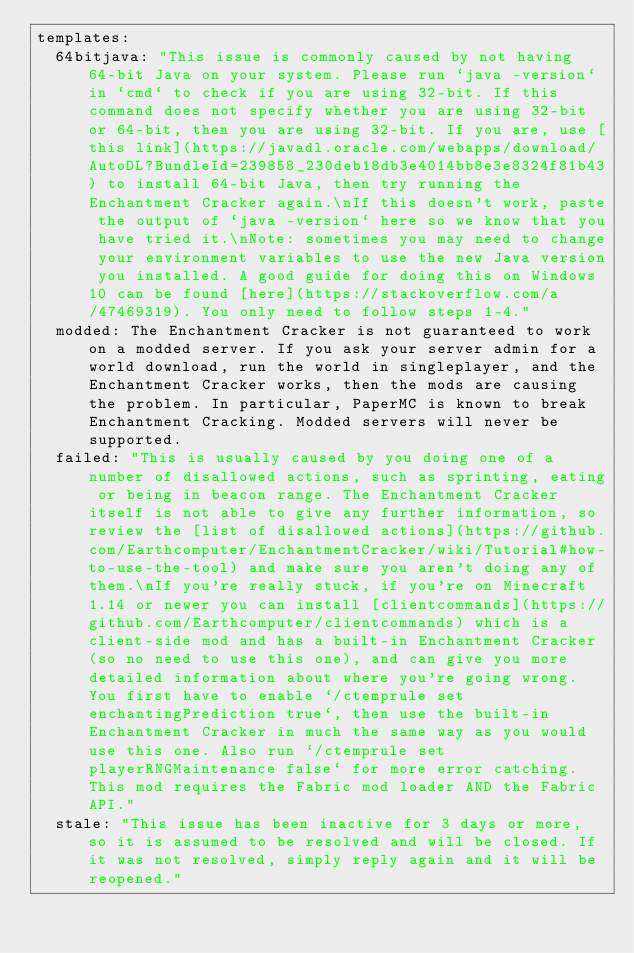Convert code to text. <code><loc_0><loc_0><loc_500><loc_500><_YAML_>templates:
  64bitjava: "This issue is commonly caused by not having 64-bit Java on your system. Please run `java -version` in `cmd` to check if you are using 32-bit. If this command does not specify whether you are using 32-bit or 64-bit, then you are using 32-bit. If you are, use [this link](https://javadl.oracle.com/webapps/download/AutoDL?BundleId=239858_230deb18db3e4014bb8e3e8324f81b43) to install 64-bit Java, then try running the Enchantment Cracker again.\nIf this doesn't work, paste the output of `java -version` here so we know that you have tried it.\nNote: sometimes you may need to change your environment variables to use the new Java version you installed. A good guide for doing this on Windows 10 can be found [here](https://stackoverflow.com/a/47469319). You only need to follow steps 1-4."
  modded: The Enchantment Cracker is not guaranteed to work on a modded server. If you ask your server admin for a world download, run the world in singleplayer, and the Enchantment Cracker works, then the mods are causing the problem. In particular, PaperMC is known to break Enchantment Cracking. Modded servers will never be supported.
  failed: "This is usually caused by you doing one of a number of disallowed actions, such as sprinting, eating or being in beacon range. The Enchantment Cracker itself is not able to give any further information, so review the [list of disallowed actions](https://github.com/Earthcomputer/EnchantmentCracker/wiki/Tutorial#how-to-use-the-tool) and make sure you aren't doing any of them.\nIf you're really stuck, if you're on Minecraft 1.14 or newer you can install [clientcommands](https://github.com/Earthcomputer/clientcommands) which is a client-side mod and has a built-in Enchantment Cracker (so no need to use this one), and can give you more detailed information about where you're going wrong. You first have to enable `/ctemprule set enchantingPrediction true`, then use the built-in Enchantment Cracker in much the same way as you would use this one. Also run `/ctemprule set playerRNGMaintenance false` for more error catching. This mod requires the Fabric mod loader AND the Fabric API."
  stale: "This issue has been inactive for 3 days or more, so it is assumed to be resolved and will be closed. If it was not resolved, simply reply again and it will be reopened."
</code> 